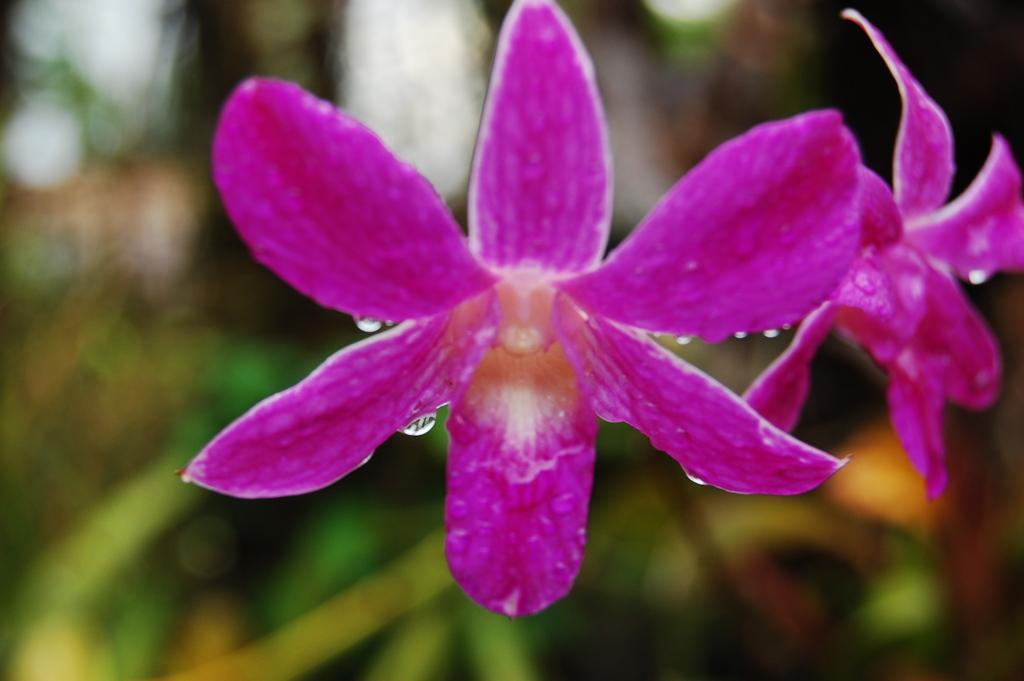Please provide a concise description of this image. This is the picture of a flower. In this image there are two pink color flowers on the plant. At the back the image is blurry. 